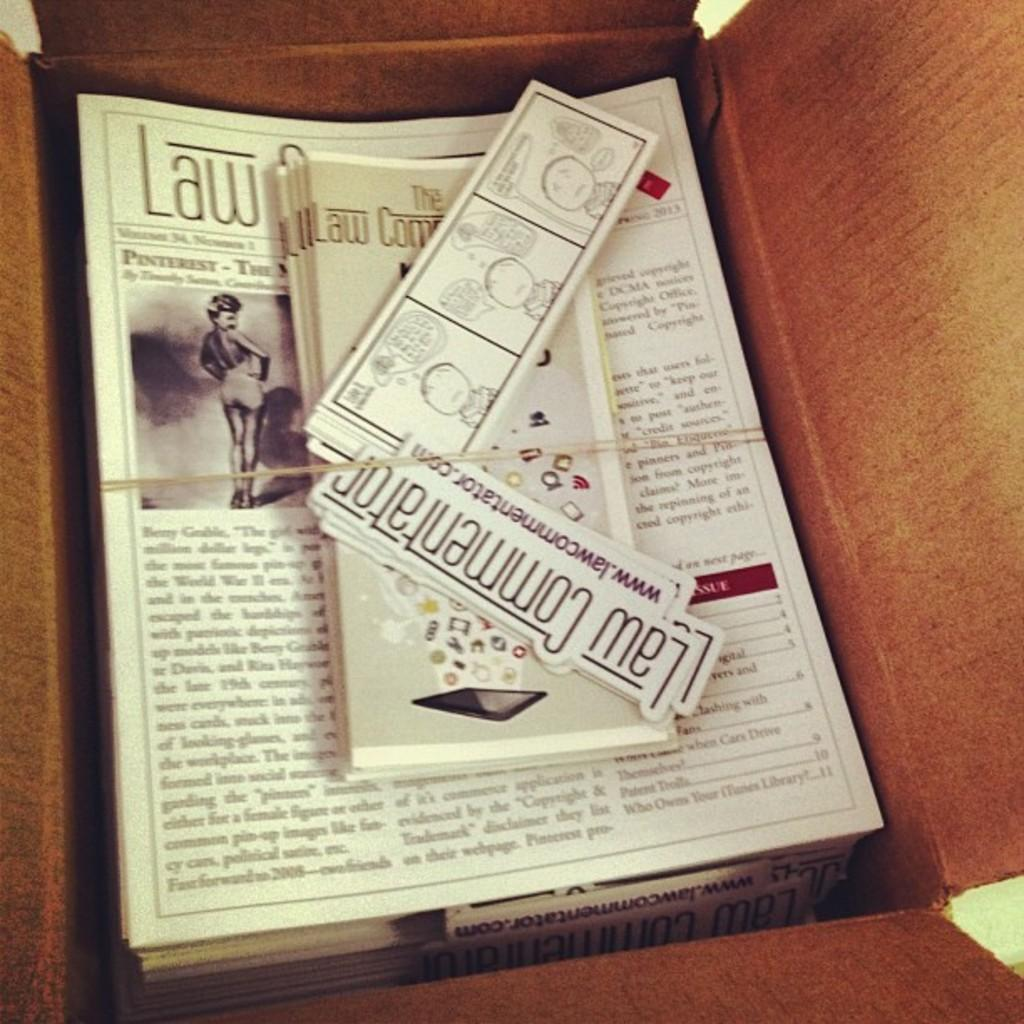<image>
Describe the image concisely. A stack of stuff with a rubber band around it has Law Commentator stickers on top. 